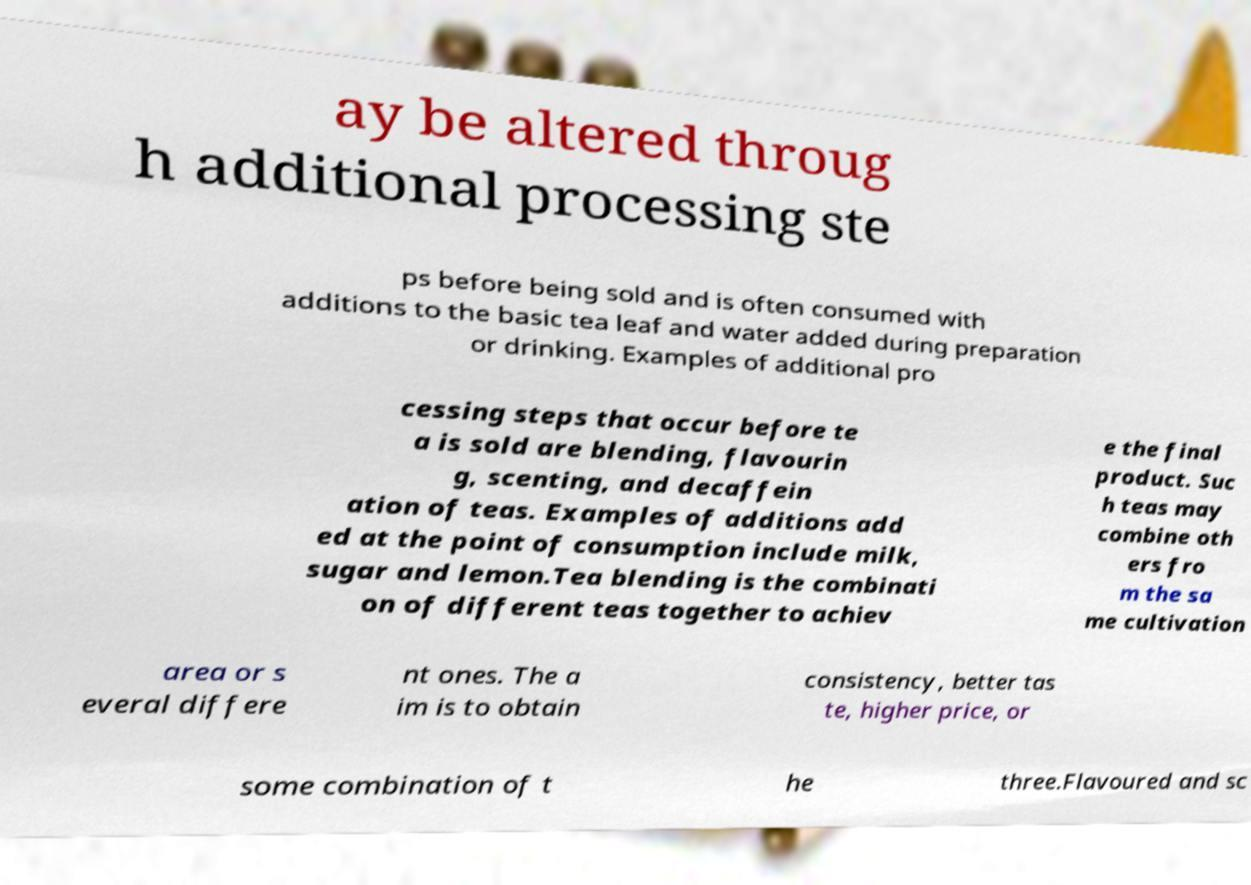I need the written content from this picture converted into text. Can you do that? ay be altered throug h additional processing ste ps before being sold and is often consumed with additions to the basic tea leaf and water added during preparation or drinking. Examples of additional pro cessing steps that occur before te a is sold are blending, flavourin g, scenting, and decaffein ation of teas. Examples of additions add ed at the point of consumption include milk, sugar and lemon.Tea blending is the combinati on of different teas together to achiev e the final product. Suc h teas may combine oth ers fro m the sa me cultivation area or s everal differe nt ones. The a im is to obtain consistency, better tas te, higher price, or some combination of t he three.Flavoured and sc 